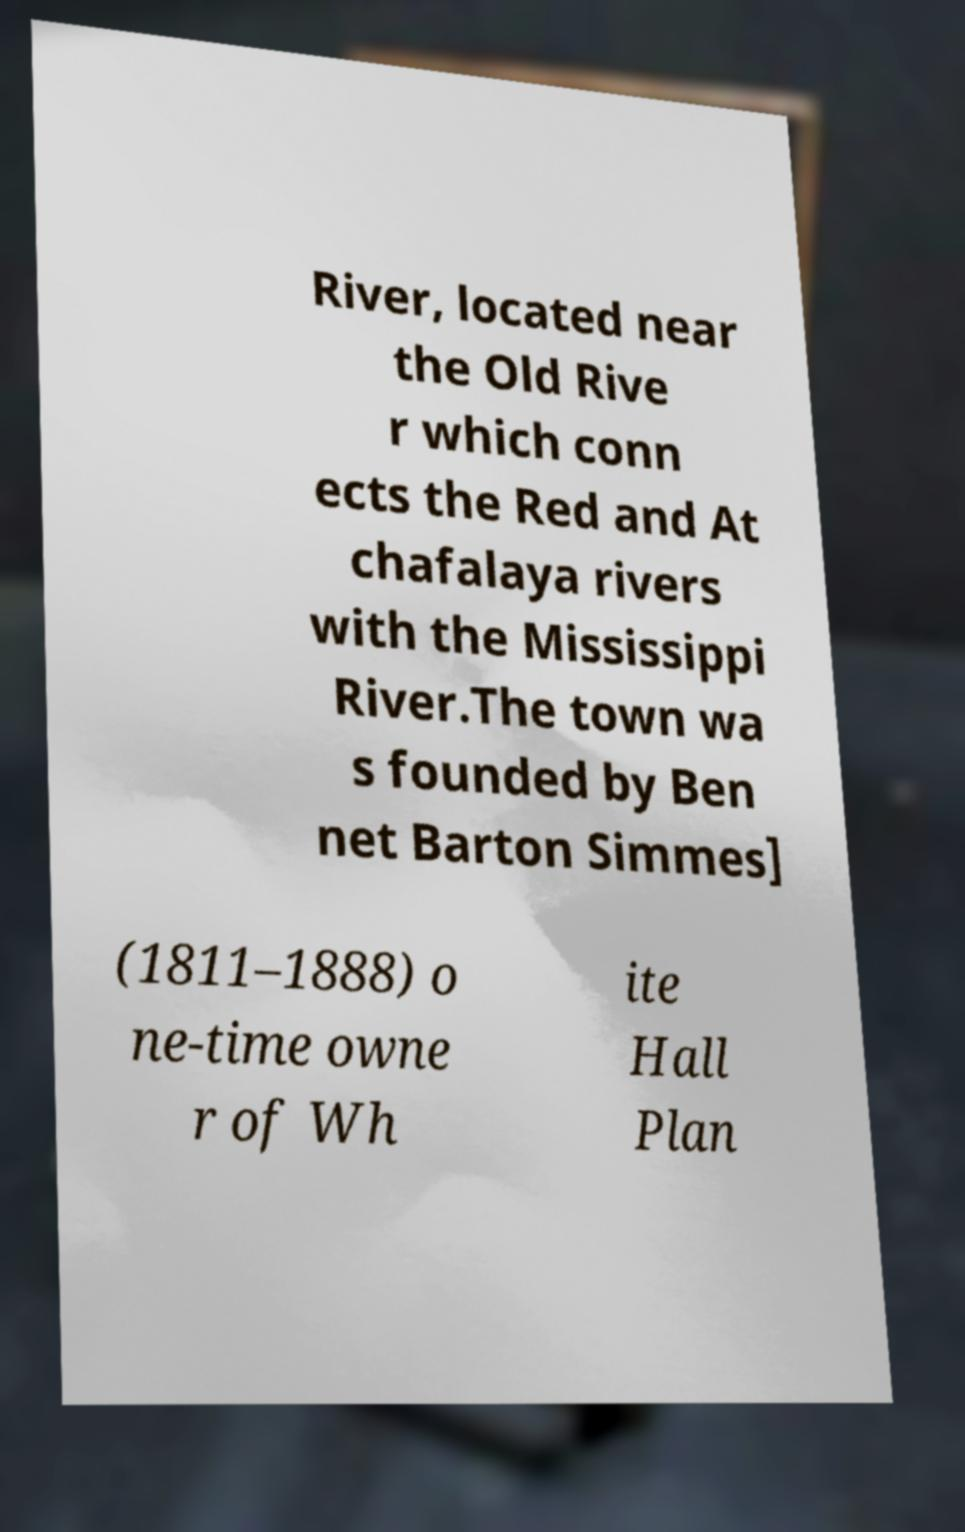Could you assist in decoding the text presented in this image and type it out clearly? River, located near the Old Rive r which conn ects the Red and At chafalaya rivers with the Mississippi River.The town wa s founded by Ben net Barton Simmes] (1811–1888) o ne-time owne r of Wh ite Hall Plan 